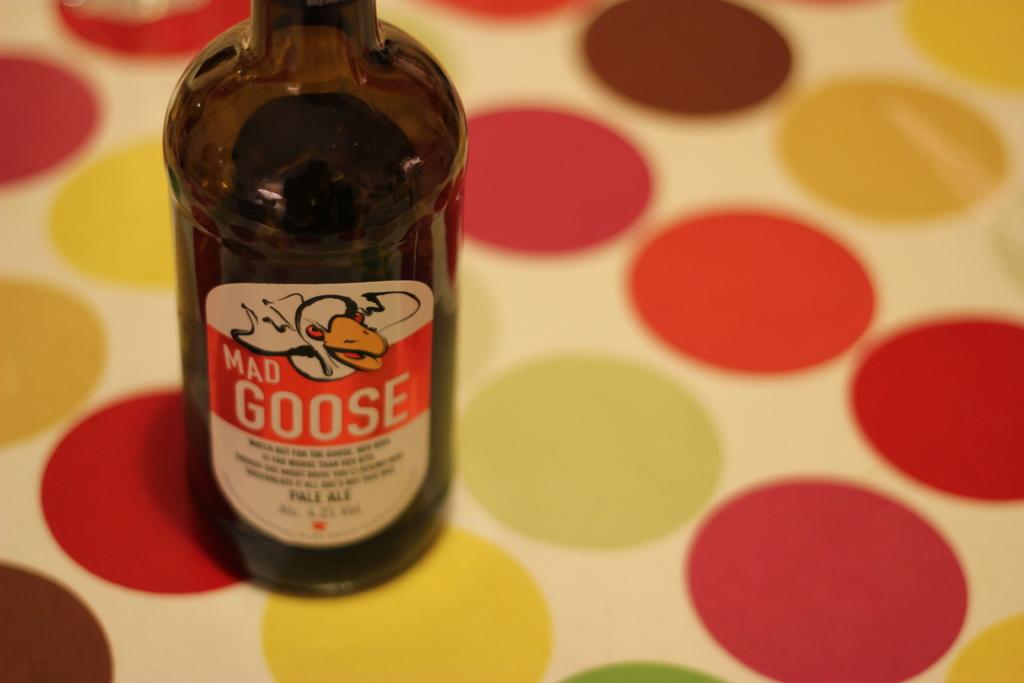What is the brand name?
Give a very brief answer. Mad goose. 